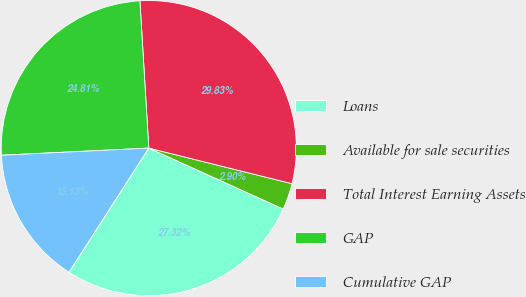Convert chart to OTSL. <chart><loc_0><loc_0><loc_500><loc_500><pie_chart><fcel>Loans<fcel>Available for sale securities<fcel>Total Interest Earning Assets<fcel>GAP<fcel>Cumulative GAP<nl><fcel>27.32%<fcel>2.9%<fcel>29.83%<fcel>24.81%<fcel>15.13%<nl></chart> 